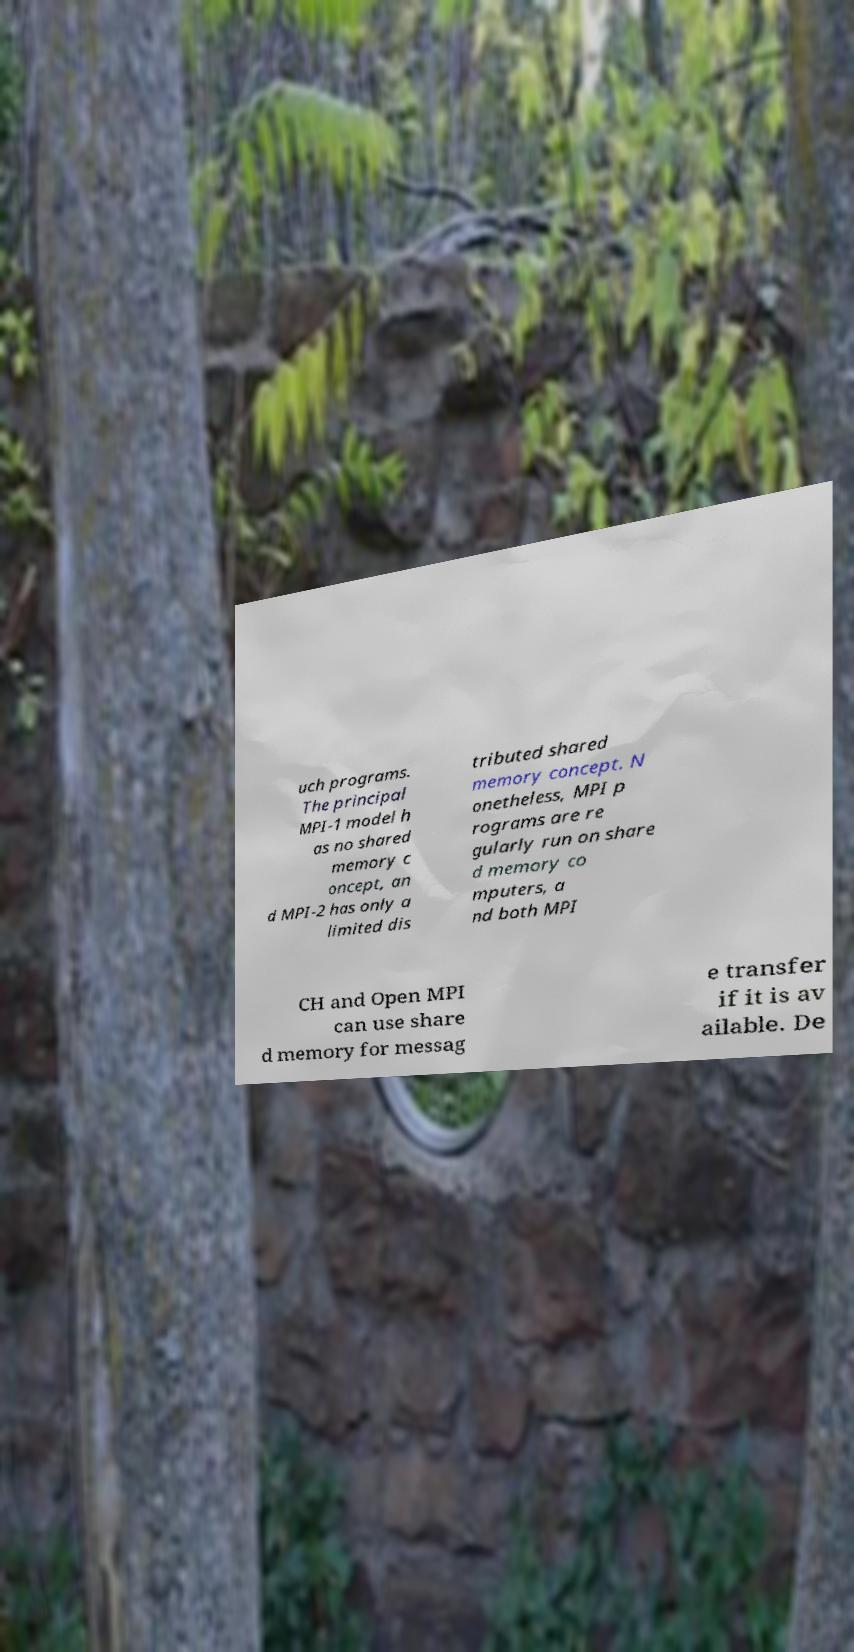Can you accurately transcribe the text from the provided image for me? uch programs. The principal MPI-1 model h as no shared memory c oncept, an d MPI-2 has only a limited dis tributed shared memory concept. N onetheless, MPI p rograms are re gularly run on share d memory co mputers, a nd both MPI CH and Open MPI can use share d memory for messag e transfer if it is av ailable. De 